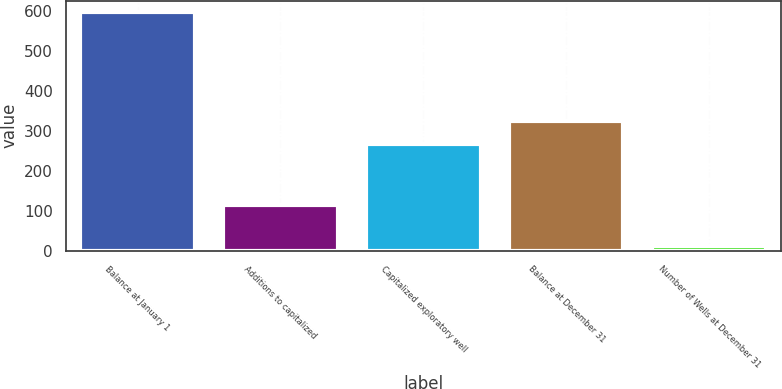<chart> <loc_0><loc_0><loc_500><loc_500><bar_chart><fcel>Balance at January 1<fcel>Additions to capitalized<fcel>Capitalized exploratory well<fcel>Balance at December 31<fcel>Number of Wells at December 31<nl><fcel>597<fcel>116<fcel>268<fcel>326.5<fcel>12<nl></chart> 